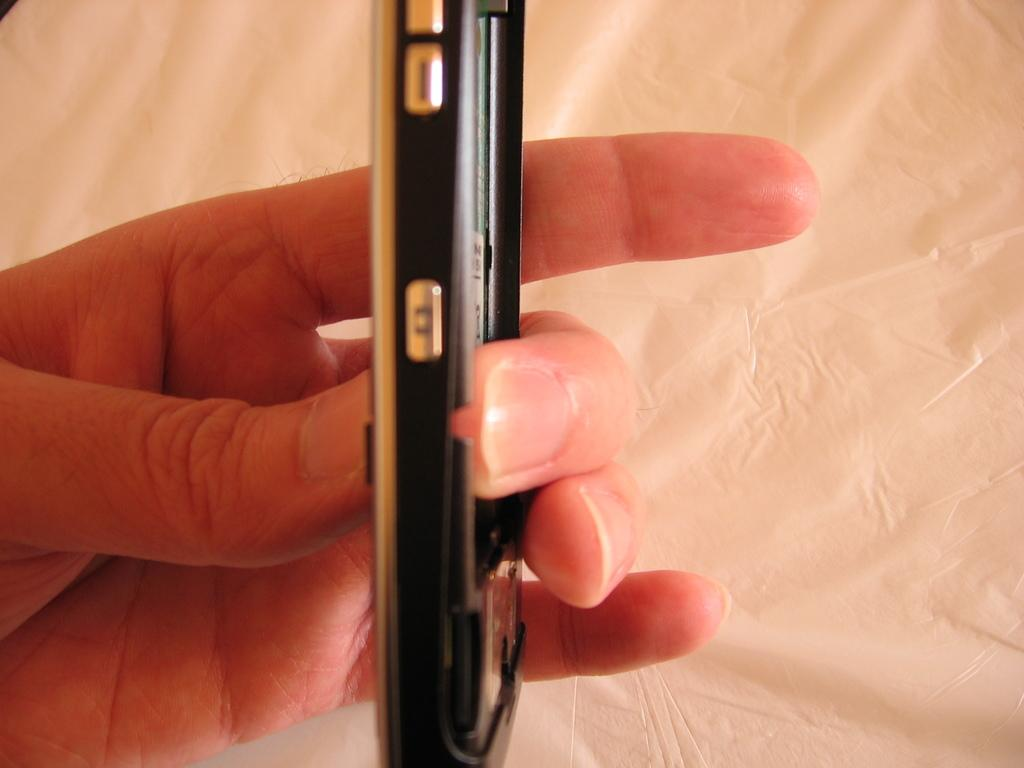What is the hand in the image holding? The hand is holding a mobile phone. What can be seen at the bottom of the image? There is a white cloth at the bottom of the image. How many babies are visible in the image? There are no babies present in the image. What type of heart is shown beating in the image? There is no heart visible in the image. 